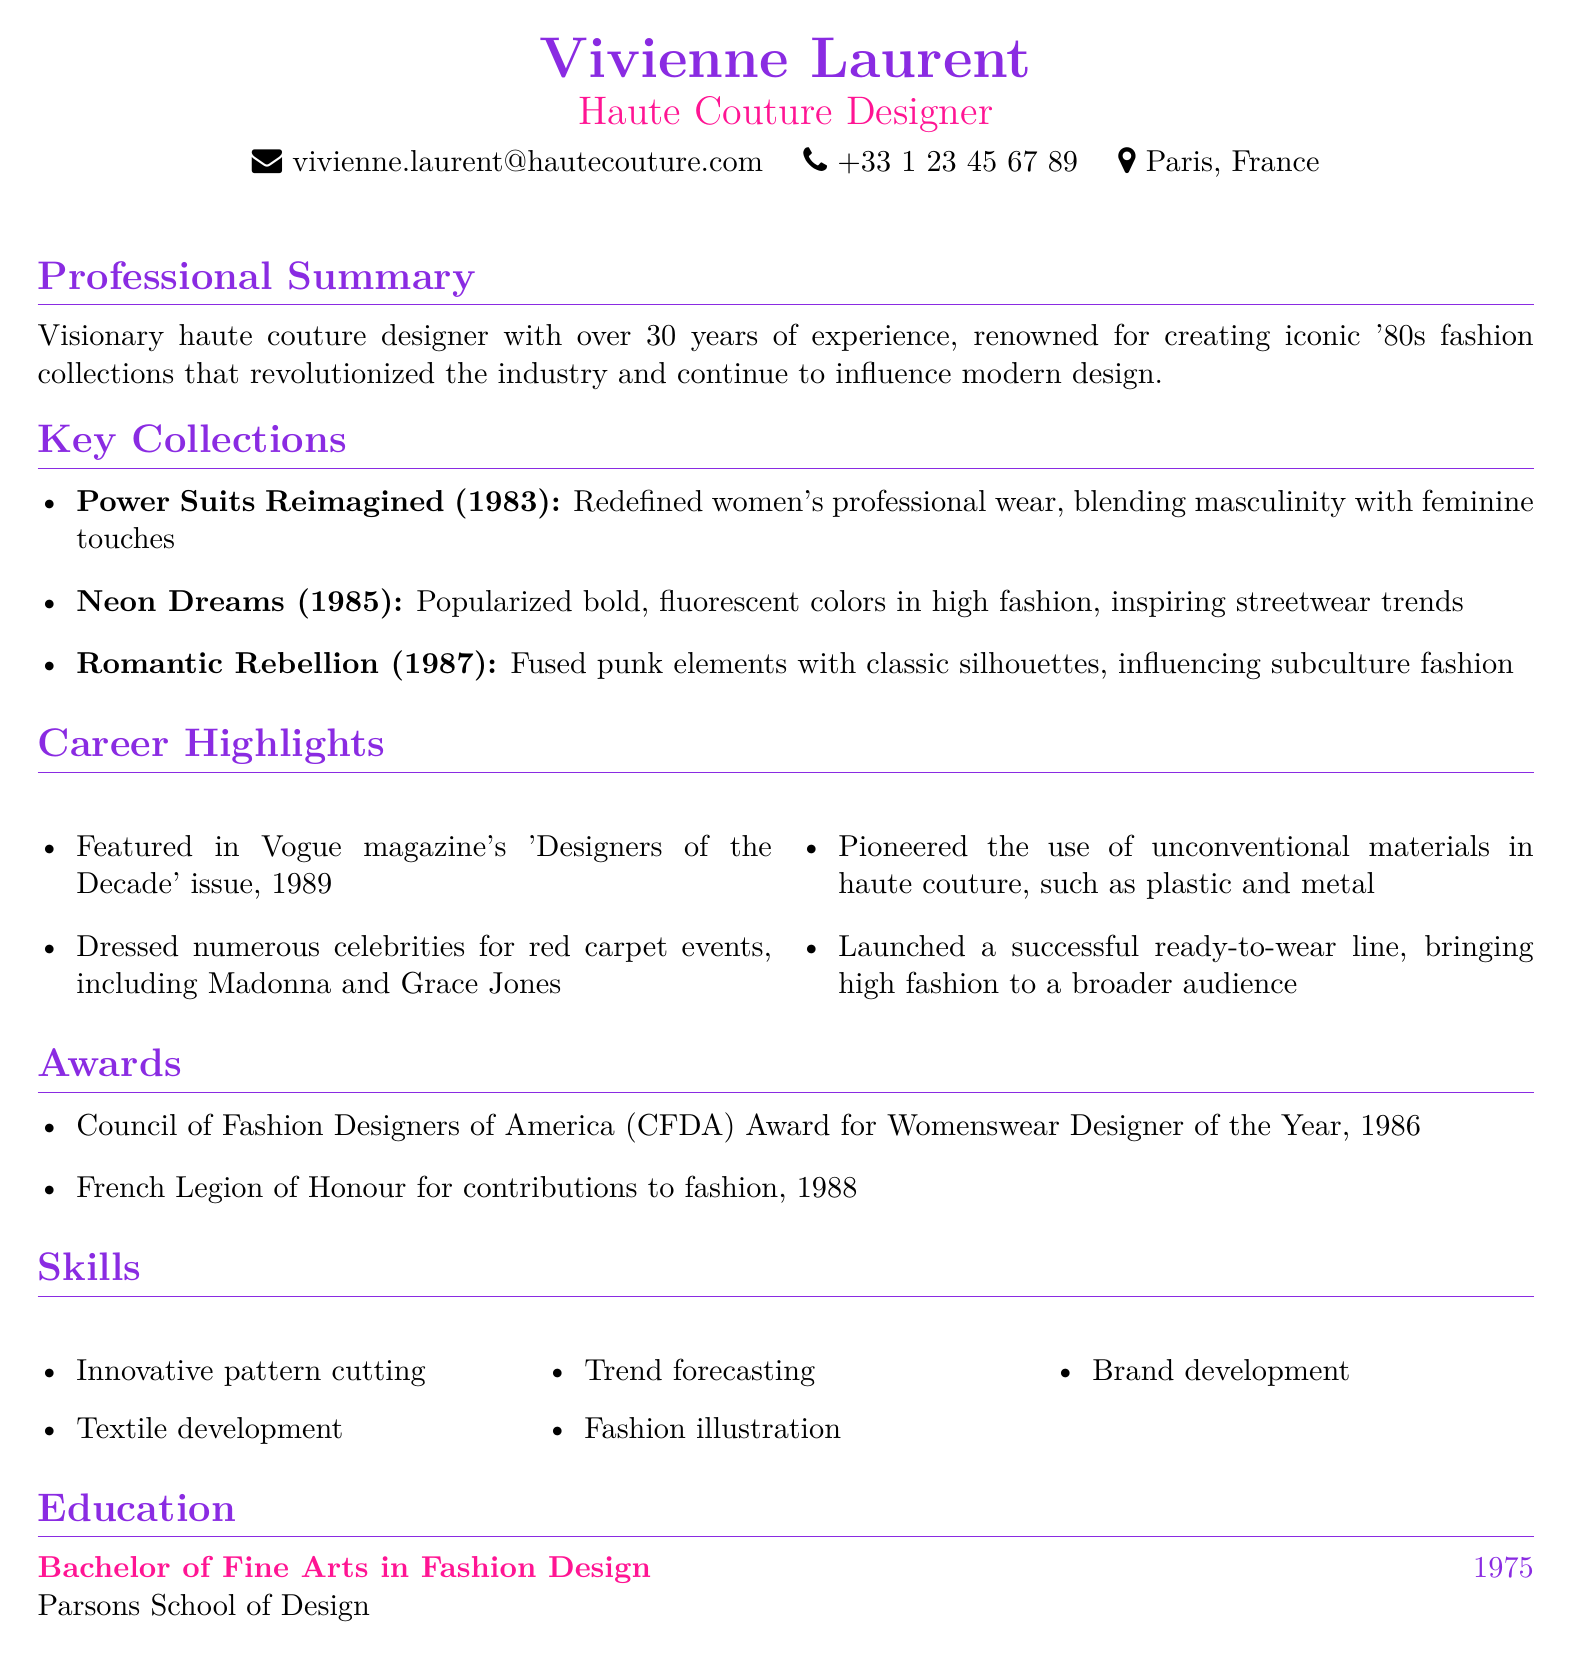What is the name of the designer? The name of the designer is mentioned at the top of the document.
Answer: Vivienne Laurent What year was the collection "Power Suits Reimagined" released? The year of the collection is provided in the Key Collections section.
Answer: 1983 Which award did Vivienne Laurent receive in 1986? The award details are listed in the Awards section of the document.
Answer: CFDA Award for Womenswear Designer of the Year What is the primary location listed for contact? The primary location is stated in the contact information section.
Answer: Paris, France How many years of experience does Vivienne Laurent have? The total years of experience is mentioned in the Professional Summary.
Answer: 30 years What impact did the collection "Neon Dreams" have on fashion? The impact is described in the Key Collections section of the document.
Answer: Popularized bold, fluorescent colors Which prestigious publication featured her in 1989? This information is found in the Career Highlights section.
Answer: Vogue What degree did Vivienne Laurent earn? The education details specify the degree attained.
Answer: Bachelor of Fine Arts in Fashion Design What skill is associated with textile development? The specific skill is listed in the Skills section of the document.
Answer: Textile development 